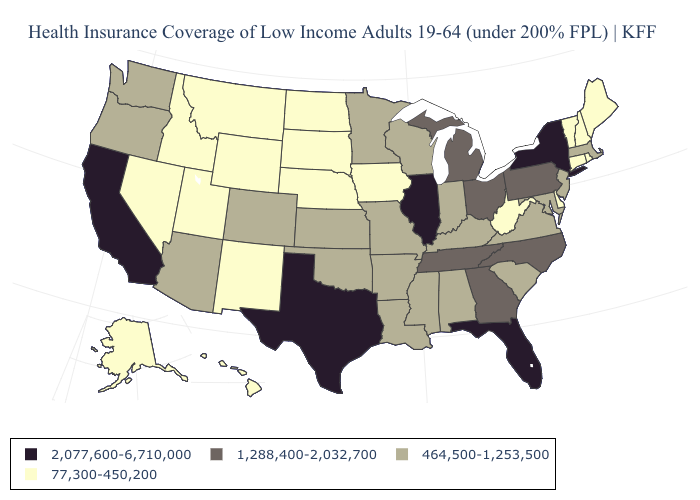Does Alaska have the lowest value in the USA?
Short answer required. Yes. What is the highest value in states that border South Carolina?
Concise answer only. 1,288,400-2,032,700. Among the states that border Ohio , does Pennsylvania have the highest value?
Answer briefly. Yes. Does Utah have a lower value than Minnesota?
Write a very short answer. Yes. Which states have the lowest value in the Northeast?
Keep it brief. Connecticut, Maine, New Hampshire, Rhode Island, Vermont. Among the states that border Delaware , does Pennsylvania have the lowest value?
Answer briefly. No. What is the value of Ohio?
Answer briefly. 1,288,400-2,032,700. What is the value of Vermont?
Quick response, please. 77,300-450,200. What is the highest value in states that border Alabama?
Answer briefly. 2,077,600-6,710,000. What is the highest value in states that border South Carolina?
Quick response, please. 1,288,400-2,032,700. Name the states that have a value in the range 77,300-450,200?
Give a very brief answer. Alaska, Connecticut, Delaware, Hawaii, Idaho, Iowa, Maine, Montana, Nebraska, Nevada, New Hampshire, New Mexico, North Dakota, Rhode Island, South Dakota, Utah, Vermont, West Virginia, Wyoming. Name the states that have a value in the range 464,500-1,253,500?
Keep it brief. Alabama, Arizona, Arkansas, Colorado, Indiana, Kansas, Kentucky, Louisiana, Maryland, Massachusetts, Minnesota, Mississippi, Missouri, New Jersey, Oklahoma, Oregon, South Carolina, Virginia, Washington, Wisconsin. Does Missouri have a lower value than Texas?
Quick response, please. Yes. What is the value of Vermont?
Concise answer only. 77,300-450,200. What is the highest value in the MidWest ?
Be succinct. 2,077,600-6,710,000. 